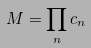<formula> <loc_0><loc_0><loc_500><loc_500>M = \prod _ { n } c _ { n }</formula> 